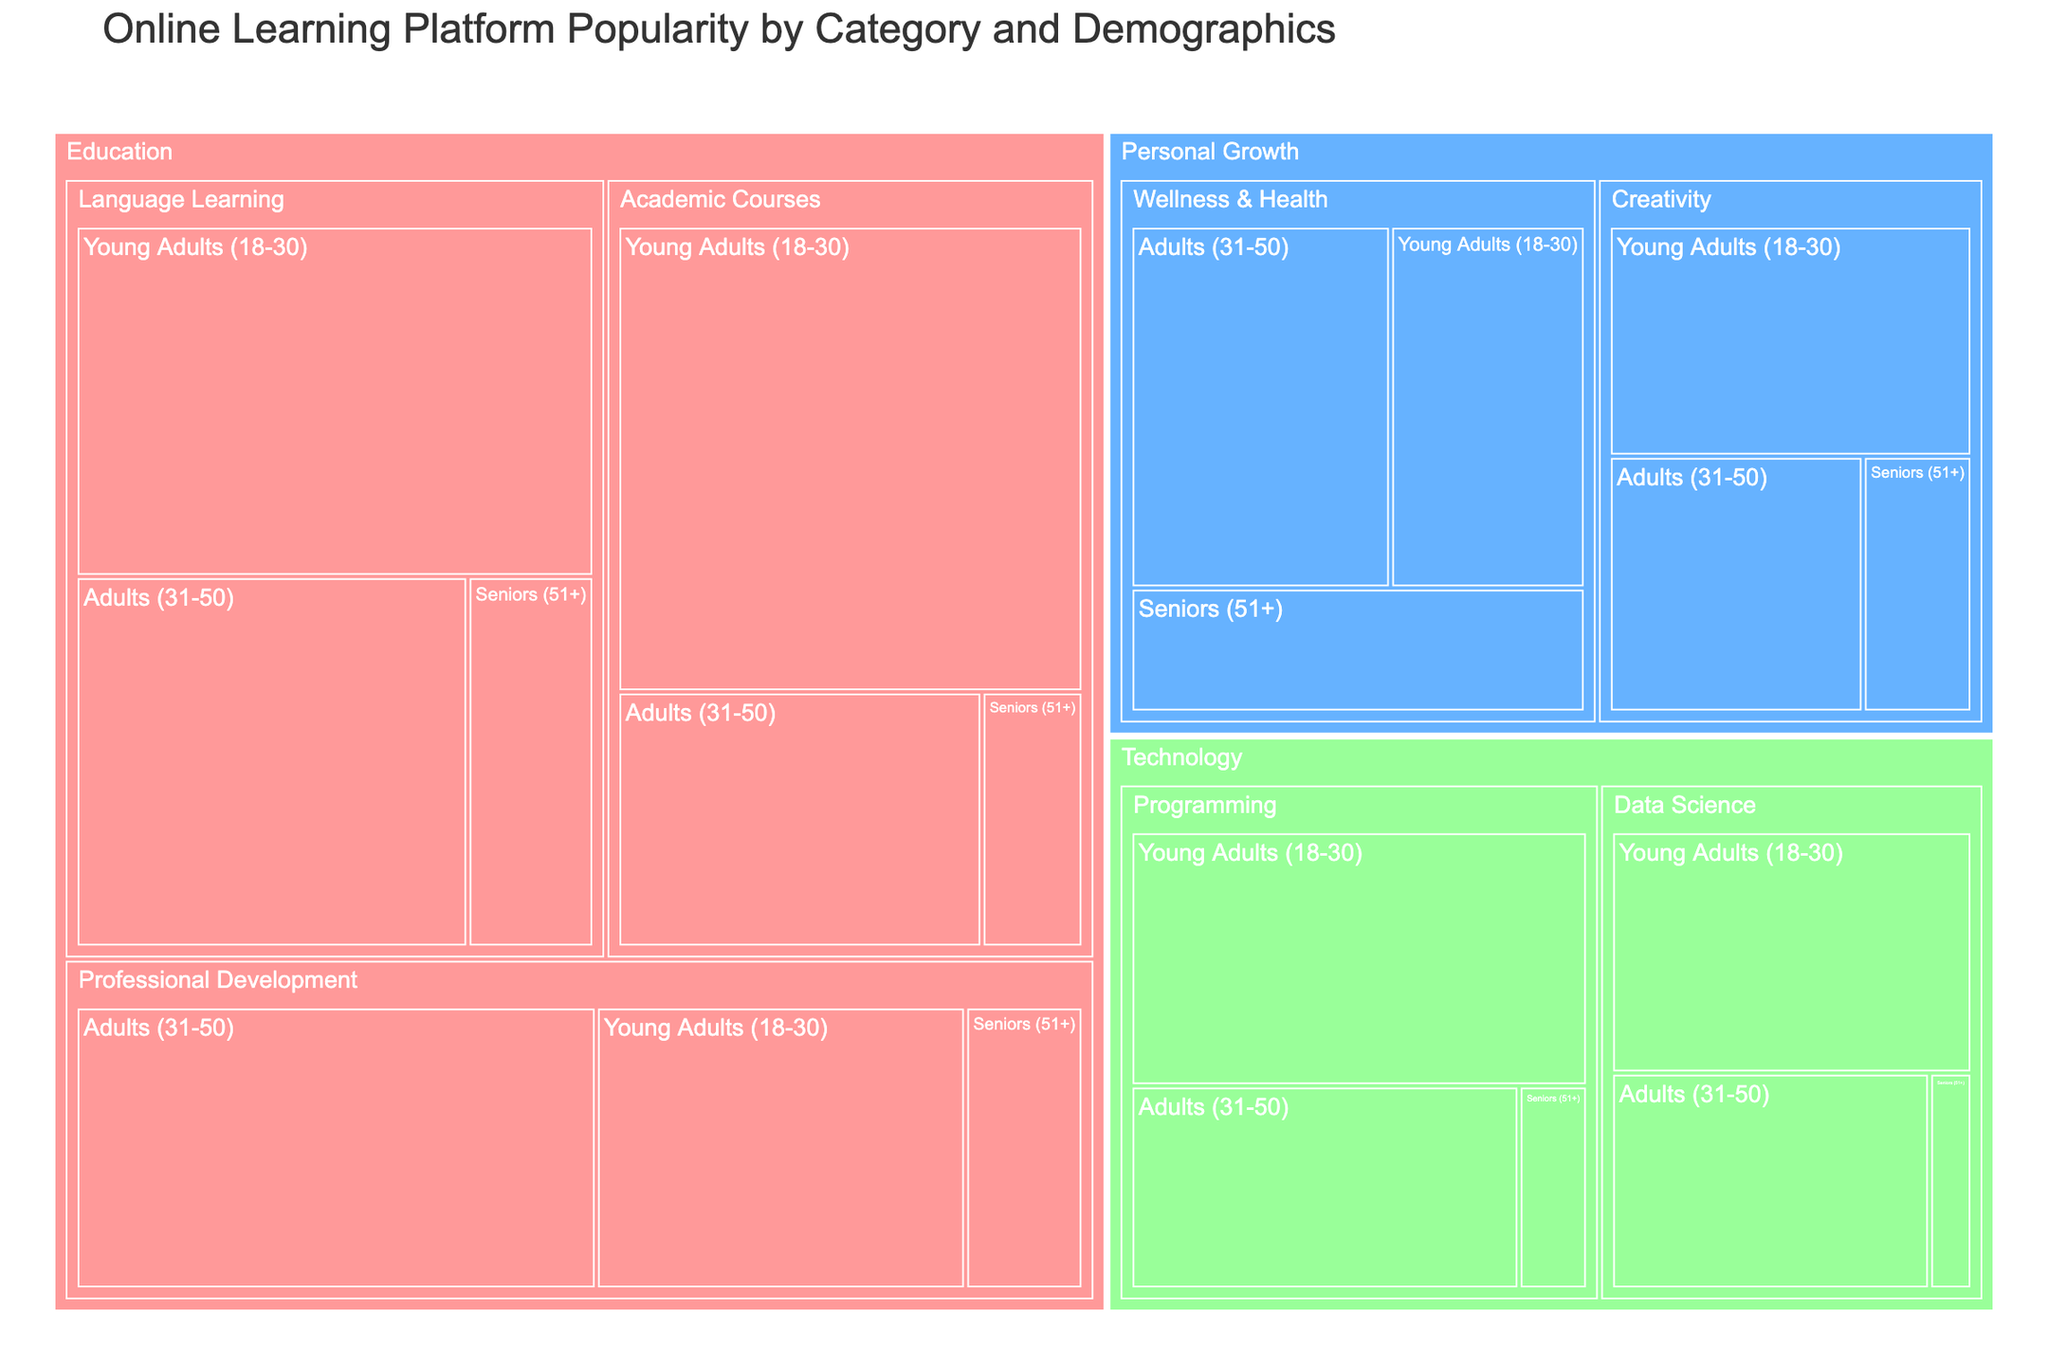How many total users are there in the Professional Development subcategory? First, locate the Professional Development subcategory under the Education category. Sum the number of users across all user demographics: 2,200,000 (Young Adults) + 3,100,000 (Adults) + 700,000 (Seniors) = 6,000,000 users.
Answer: 6,000,000 Which user demographic has the highest number of users in the Language Learning subcategory? In the Language Learning subcategory under the Education category, compare the number of users across different user demographics: Young Adults (3,500,000), Adults (2,800,000), and Seniors (900,000). The highest number is 3,500,000 users for Young Adults.
Answer: Young Adults (18-30) What is the total number of users in the Education category? Sum the number of users across all subcategories and demographics within the Education category: Language Learning total (3,500,000 + 2,800,000 + 900,000) + Professional Development total (2,200,000 + 3,100,000 + 700,000) + Academic Courses total (4,200,000 + 1,800,000 + 500,000). This results in 7,200,000 + 6,000,000 + 6,500,000 = 19,700,000 users.
Answer: 19,700,000 Compare the number of users in Programming between Young Adults and Adults. In the Programming subcategory under the Technology category, note the number of users for Young Adults (2,500,000) and Adults (1,700,000). Compare the two numbers.
Answer: Young Adults have more users (2,500,000) Which subcategory in the Personal Growth category has more users for Seniors, Wellness & Health or Creativity? In the Wellness & Health subcategory, Seniors have 1,200,000 users. In the Creativity subcategory, Seniors have 600,000 users. Compare these two numbers.
Answer: Wellness & Health How many more users are there in the Data Science subcategory among Young Adults compared to Seniors? In the Data Science subcategory under the Technology category, note the users for Young Adults (1,900,000) and Seniors (200,000). Subtract the number of Senior users from Young Adult users: 1,900,000 - 200,000 = 1,700,000 more users.
Answer: 1,700,000 Which subcategory in the Technology category has the least number of users among all user demographics combined? Sum the number of users for each subcategory in Technology. Data Science total: 1,900,000 (Young Adults) + 1,500,000 (Adults) + 200,000 (Seniors) = 3,600,000. Programming total: 2,500,000 (Young Adults) + 1,700,000 (Adults) + 300,000 (Seniors) = 4,500,000. Data Science has the least users with 3,600,000.
Answer: Data Science 